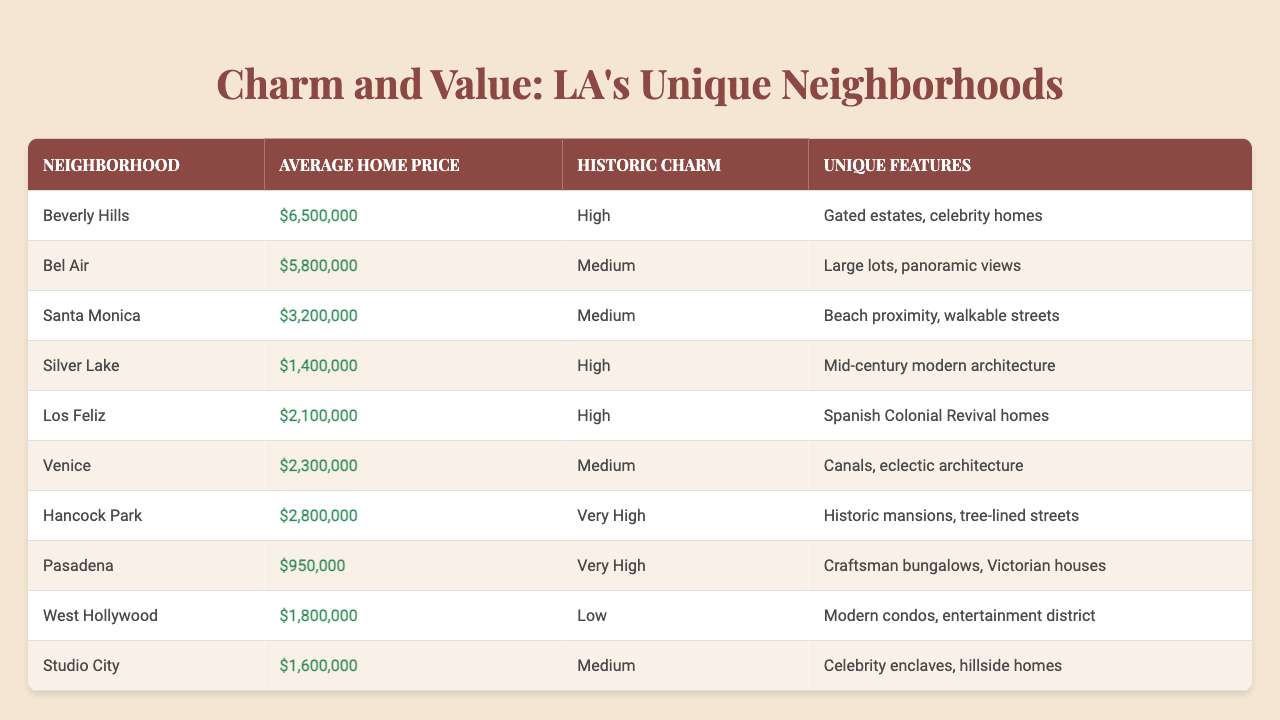What is the average home price in Santa Monica? The table lists the average home price for Santa Monica as $3,200,000 as shown in the second column of the corresponding row.
Answer: $3,200,000 Which neighborhood has the highest average home price? The highest average home price in the table is for Beverly Hills, listed at $6,500,000, located in the first row.
Answer: Beverly Hills Is there a neighborhood with a very high historic charm and a unique feature of historic mansions? Yes, Hancock Park has a very high historic charm and is noted for its historic mansions in the unique features column.
Answer: Yes What is the average home price difference between Beverly Hills and Pasadena? The average home price for Beverly Hills is $6,500,000 and for Pasadena is $950,000. The difference is $6,500,000 - $950,000 = $5,550,000.
Answer: $5,550,000 How many neighborhoods have a medium level of historic charm? The table shows three neighborhoods listed with medium historic charm: Bel Air, Santa Monica, and Venice, which can be counted from the respective rows.
Answer: 3 Which neighborhood has a unique feature that includes walkable streets? Santa Monica has a unique feature of walkable streets, mentioned specifically in its row of the table.
Answer: Santa Monica What is the average home price for the neighborhoods listed with high historic charm? The average home prices for neighborhoods with high historic charm, namely Silver Lake, Los Feliz, and Hancock Park, are $1,400,000, $2,100,000, and $2,800,000, respectively. To find the average: ($1,400,000 + $2,100,000 + $2,800,000) / 3 = $2,100,000.
Answer: $2,100,000 Is Venice the only neighborhood with canals as a unique feature? Yes, the table specifies that Venice is the only neighborhood identified to have canals listed in the unique features.
Answer: Yes How does the average home price of Studio City compare to that of West Hollywood? Studio City has an average home price of $1,600,000 while West Hollywood's is $1,800,000. The comparison shows that West Hollywood's price is higher. Therefore, $1,800,000 - $1,600,000 = $200,000.
Answer: $200,000 Which neighborhood has the lowest average home price and unique features? Pasadena has the lowest average home price of $950,000, and it features Craftsman bungalows and Victorian houses listed in the respective column.
Answer: Pasadena 